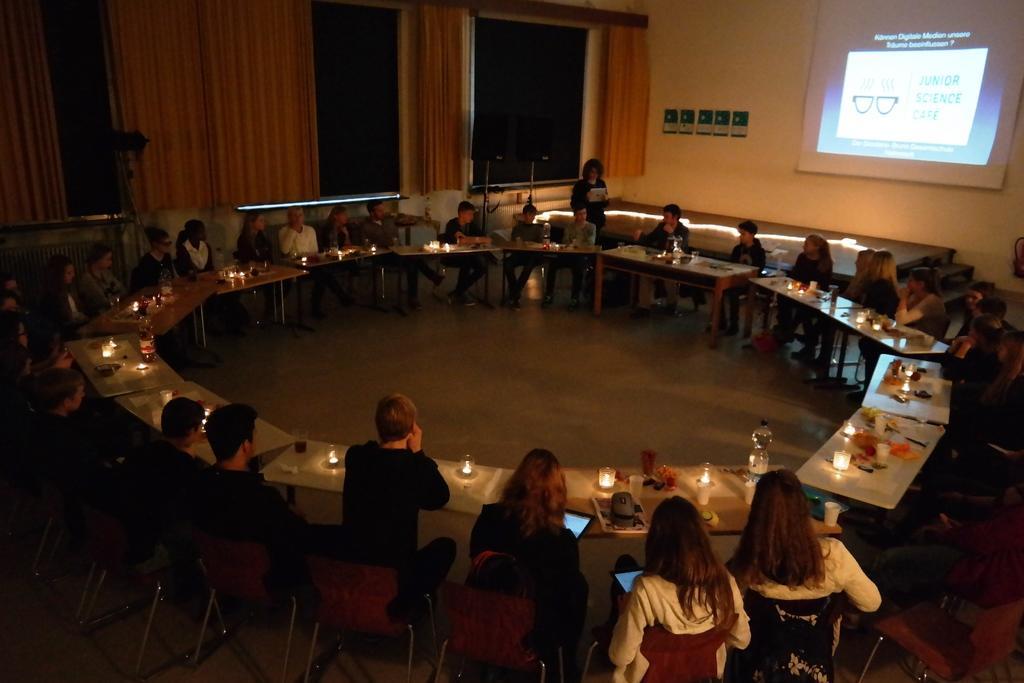Please provide a concise description of this image. In this picture there are group of people sitting on the chair. There is a bottle, candles, glass , cup on the table. There is a woman standing. There is a screen There is a cream curtain. 